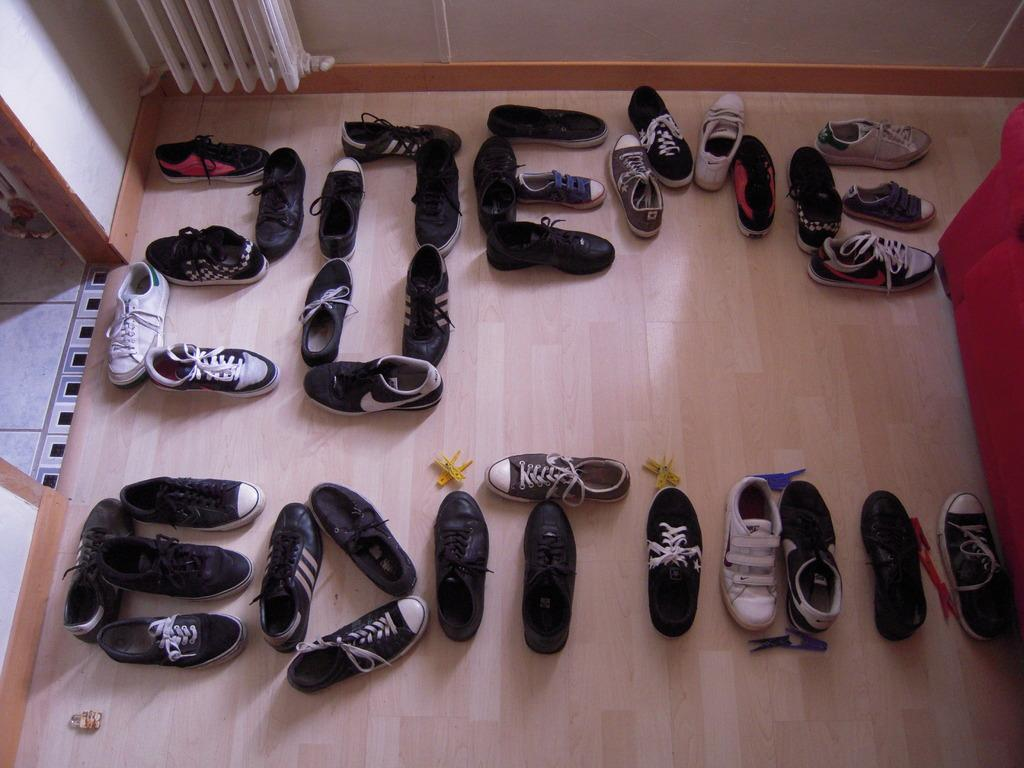What type of view is shown in the image? The image is an inside view. What objects can be seen on the floor? There are shoes on the floor. What color and type of furniture is on the right side of the image? There is a red color couch on the right side. What is visible at the top of the image? The top of the image shows a wall. Can you see a mitten being used to run on the wall in the image? There is no mitten or running depicted on the wall in the image. Is there a horse visible in the image? There is no horse present in the image. 